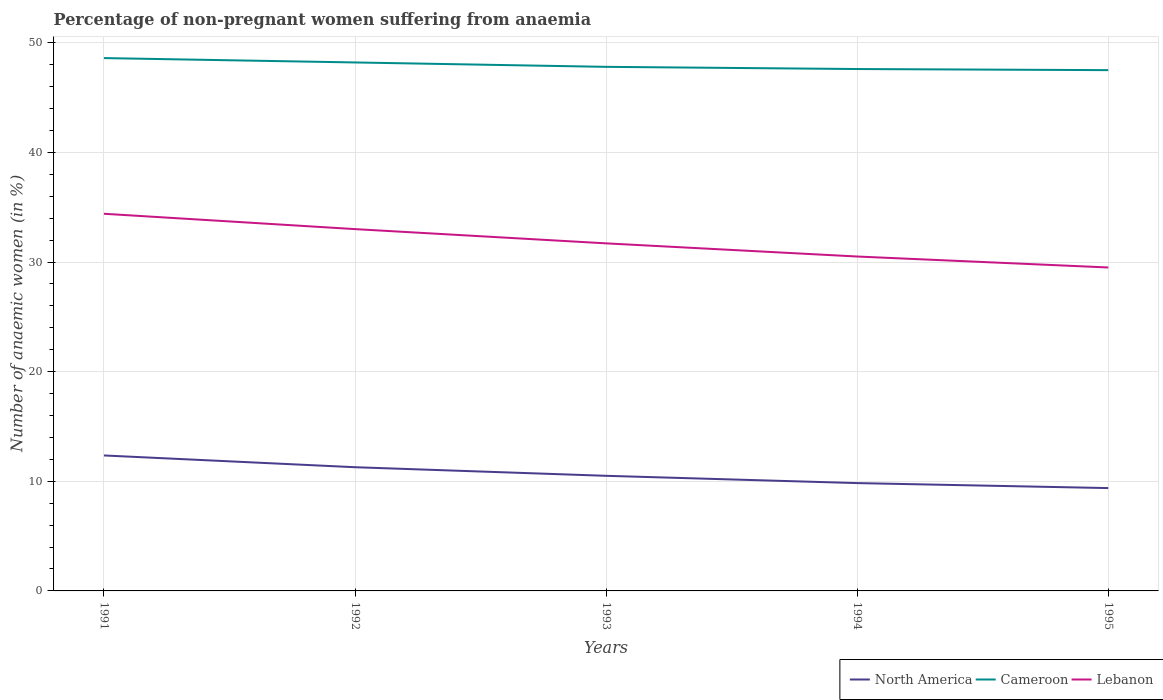How many different coloured lines are there?
Give a very brief answer. 3. Does the line corresponding to North America intersect with the line corresponding to Cameroon?
Your answer should be compact. No. Across all years, what is the maximum percentage of non-pregnant women suffering from anaemia in North America?
Offer a very short reply. 9.38. What is the total percentage of non-pregnant women suffering from anaemia in North America in the graph?
Keep it short and to the point. 1.45. What is the difference between the highest and the second highest percentage of non-pregnant women suffering from anaemia in Cameroon?
Your response must be concise. 1.1. What is the difference between the highest and the lowest percentage of non-pregnant women suffering from anaemia in Cameroon?
Keep it short and to the point. 2. Is the percentage of non-pregnant women suffering from anaemia in Cameroon strictly greater than the percentage of non-pregnant women suffering from anaemia in North America over the years?
Ensure brevity in your answer.  No. How many lines are there?
Offer a terse response. 3. How many years are there in the graph?
Provide a short and direct response. 5. Does the graph contain grids?
Keep it short and to the point. Yes. Where does the legend appear in the graph?
Give a very brief answer. Bottom right. How many legend labels are there?
Offer a very short reply. 3. How are the legend labels stacked?
Your response must be concise. Horizontal. What is the title of the graph?
Your response must be concise. Percentage of non-pregnant women suffering from anaemia. Does "Kiribati" appear as one of the legend labels in the graph?
Provide a succinct answer. No. What is the label or title of the Y-axis?
Your answer should be compact. Number of anaemic women (in %). What is the Number of anaemic women (in %) in North America in 1991?
Your answer should be very brief. 12.36. What is the Number of anaemic women (in %) in Cameroon in 1991?
Make the answer very short. 48.6. What is the Number of anaemic women (in %) of Lebanon in 1991?
Offer a very short reply. 34.4. What is the Number of anaemic women (in %) of North America in 1992?
Your answer should be compact. 11.28. What is the Number of anaemic women (in %) of Cameroon in 1992?
Your response must be concise. 48.2. What is the Number of anaemic women (in %) in Lebanon in 1992?
Ensure brevity in your answer.  33. What is the Number of anaemic women (in %) in North America in 1993?
Offer a very short reply. 10.5. What is the Number of anaemic women (in %) in Cameroon in 1993?
Offer a terse response. 47.8. What is the Number of anaemic women (in %) of Lebanon in 1993?
Your answer should be very brief. 31.7. What is the Number of anaemic women (in %) in North America in 1994?
Offer a very short reply. 9.83. What is the Number of anaemic women (in %) of Cameroon in 1994?
Keep it short and to the point. 47.6. What is the Number of anaemic women (in %) in Lebanon in 1994?
Ensure brevity in your answer.  30.5. What is the Number of anaemic women (in %) in North America in 1995?
Give a very brief answer. 9.38. What is the Number of anaemic women (in %) in Cameroon in 1995?
Your response must be concise. 47.5. What is the Number of anaemic women (in %) in Lebanon in 1995?
Make the answer very short. 29.5. Across all years, what is the maximum Number of anaemic women (in %) of North America?
Your response must be concise. 12.36. Across all years, what is the maximum Number of anaemic women (in %) of Cameroon?
Give a very brief answer. 48.6. Across all years, what is the maximum Number of anaemic women (in %) of Lebanon?
Your response must be concise. 34.4. Across all years, what is the minimum Number of anaemic women (in %) of North America?
Make the answer very short. 9.38. Across all years, what is the minimum Number of anaemic women (in %) of Cameroon?
Offer a terse response. 47.5. Across all years, what is the minimum Number of anaemic women (in %) in Lebanon?
Provide a succinct answer. 29.5. What is the total Number of anaemic women (in %) of North America in the graph?
Keep it short and to the point. 53.35. What is the total Number of anaemic women (in %) of Cameroon in the graph?
Your answer should be very brief. 239.7. What is the total Number of anaemic women (in %) of Lebanon in the graph?
Your answer should be very brief. 159.1. What is the difference between the Number of anaemic women (in %) in North America in 1991 and that in 1992?
Make the answer very short. 1.07. What is the difference between the Number of anaemic women (in %) of Cameroon in 1991 and that in 1992?
Give a very brief answer. 0.4. What is the difference between the Number of anaemic women (in %) of North America in 1991 and that in 1993?
Your response must be concise. 1.86. What is the difference between the Number of anaemic women (in %) of Lebanon in 1991 and that in 1993?
Offer a terse response. 2.7. What is the difference between the Number of anaemic women (in %) in North America in 1991 and that in 1994?
Your answer should be compact. 2.52. What is the difference between the Number of anaemic women (in %) in Lebanon in 1991 and that in 1994?
Offer a terse response. 3.9. What is the difference between the Number of anaemic women (in %) of North America in 1991 and that in 1995?
Give a very brief answer. 2.98. What is the difference between the Number of anaemic women (in %) in Cameroon in 1991 and that in 1995?
Ensure brevity in your answer.  1.1. What is the difference between the Number of anaemic women (in %) of North America in 1992 and that in 1993?
Provide a succinct answer. 0.78. What is the difference between the Number of anaemic women (in %) of Cameroon in 1992 and that in 1993?
Keep it short and to the point. 0.4. What is the difference between the Number of anaemic women (in %) of Lebanon in 1992 and that in 1993?
Keep it short and to the point. 1.3. What is the difference between the Number of anaemic women (in %) in North America in 1992 and that in 1994?
Provide a short and direct response. 1.45. What is the difference between the Number of anaemic women (in %) of North America in 1992 and that in 1995?
Provide a succinct answer. 1.9. What is the difference between the Number of anaemic women (in %) in Lebanon in 1992 and that in 1995?
Your answer should be very brief. 3.5. What is the difference between the Number of anaemic women (in %) in North America in 1993 and that in 1994?
Keep it short and to the point. 0.66. What is the difference between the Number of anaemic women (in %) of Lebanon in 1993 and that in 1994?
Your response must be concise. 1.2. What is the difference between the Number of anaemic women (in %) in North America in 1993 and that in 1995?
Provide a short and direct response. 1.12. What is the difference between the Number of anaemic women (in %) in Lebanon in 1993 and that in 1995?
Provide a succinct answer. 2.2. What is the difference between the Number of anaemic women (in %) in North America in 1994 and that in 1995?
Keep it short and to the point. 0.45. What is the difference between the Number of anaemic women (in %) in Cameroon in 1994 and that in 1995?
Give a very brief answer. 0.1. What is the difference between the Number of anaemic women (in %) of Lebanon in 1994 and that in 1995?
Offer a terse response. 1. What is the difference between the Number of anaemic women (in %) in North America in 1991 and the Number of anaemic women (in %) in Cameroon in 1992?
Keep it short and to the point. -35.84. What is the difference between the Number of anaemic women (in %) of North America in 1991 and the Number of anaemic women (in %) of Lebanon in 1992?
Offer a terse response. -20.64. What is the difference between the Number of anaemic women (in %) of Cameroon in 1991 and the Number of anaemic women (in %) of Lebanon in 1992?
Provide a succinct answer. 15.6. What is the difference between the Number of anaemic women (in %) in North America in 1991 and the Number of anaemic women (in %) in Cameroon in 1993?
Keep it short and to the point. -35.44. What is the difference between the Number of anaemic women (in %) of North America in 1991 and the Number of anaemic women (in %) of Lebanon in 1993?
Your answer should be very brief. -19.34. What is the difference between the Number of anaemic women (in %) in Cameroon in 1991 and the Number of anaemic women (in %) in Lebanon in 1993?
Your answer should be compact. 16.9. What is the difference between the Number of anaemic women (in %) of North America in 1991 and the Number of anaemic women (in %) of Cameroon in 1994?
Your response must be concise. -35.24. What is the difference between the Number of anaemic women (in %) of North America in 1991 and the Number of anaemic women (in %) of Lebanon in 1994?
Offer a very short reply. -18.14. What is the difference between the Number of anaemic women (in %) of Cameroon in 1991 and the Number of anaemic women (in %) of Lebanon in 1994?
Provide a succinct answer. 18.1. What is the difference between the Number of anaemic women (in %) in North America in 1991 and the Number of anaemic women (in %) in Cameroon in 1995?
Your answer should be very brief. -35.14. What is the difference between the Number of anaemic women (in %) in North America in 1991 and the Number of anaemic women (in %) in Lebanon in 1995?
Your answer should be compact. -17.14. What is the difference between the Number of anaemic women (in %) in Cameroon in 1991 and the Number of anaemic women (in %) in Lebanon in 1995?
Provide a succinct answer. 19.1. What is the difference between the Number of anaemic women (in %) in North America in 1992 and the Number of anaemic women (in %) in Cameroon in 1993?
Provide a short and direct response. -36.52. What is the difference between the Number of anaemic women (in %) of North America in 1992 and the Number of anaemic women (in %) of Lebanon in 1993?
Provide a short and direct response. -20.42. What is the difference between the Number of anaemic women (in %) in Cameroon in 1992 and the Number of anaemic women (in %) in Lebanon in 1993?
Offer a very short reply. 16.5. What is the difference between the Number of anaemic women (in %) of North America in 1992 and the Number of anaemic women (in %) of Cameroon in 1994?
Make the answer very short. -36.32. What is the difference between the Number of anaemic women (in %) in North America in 1992 and the Number of anaemic women (in %) in Lebanon in 1994?
Ensure brevity in your answer.  -19.22. What is the difference between the Number of anaemic women (in %) of Cameroon in 1992 and the Number of anaemic women (in %) of Lebanon in 1994?
Keep it short and to the point. 17.7. What is the difference between the Number of anaemic women (in %) in North America in 1992 and the Number of anaemic women (in %) in Cameroon in 1995?
Your response must be concise. -36.22. What is the difference between the Number of anaemic women (in %) in North America in 1992 and the Number of anaemic women (in %) in Lebanon in 1995?
Provide a succinct answer. -18.22. What is the difference between the Number of anaemic women (in %) of North America in 1993 and the Number of anaemic women (in %) of Cameroon in 1994?
Give a very brief answer. -37.1. What is the difference between the Number of anaemic women (in %) in North America in 1993 and the Number of anaemic women (in %) in Lebanon in 1994?
Your answer should be very brief. -20. What is the difference between the Number of anaemic women (in %) of Cameroon in 1993 and the Number of anaemic women (in %) of Lebanon in 1994?
Provide a short and direct response. 17.3. What is the difference between the Number of anaemic women (in %) of North America in 1993 and the Number of anaemic women (in %) of Cameroon in 1995?
Give a very brief answer. -37. What is the difference between the Number of anaemic women (in %) in North America in 1993 and the Number of anaemic women (in %) in Lebanon in 1995?
Your answer should be compact. -19. What is the difference between the Number of anaemic women (in %) of Cameroon in 1993 and the Number of anaemic women (in %) of Lebanon in 1995?
Your response must be concise. 18.3. What is the difference between the Number of anaemic women (in %) in North America in 1994 and the Number of anaemic women (in %) in Cameroon in 1995?
Your answer should be compact. -37.67. What is the difference between the Number of anaemic women (in %) of North America in 1994 and the Number of anaemic women (in %) of Lebanon in 1995?
Your answer should be compact. -19.67. What is the difference between the Number of anaemic women (in %) in Cameroon in 1994 and the Number of anaemic women (in %) in Lebanon in 1995?
Provide a short and direct response. 18.1. What is the average Number of anaemic women (in %) of North America per year?
Your answer should be very brief. 10.67. What is the average Number of anaemic women (in %) in Cameroon per year?
Your answer should be very brief. 47.94. What is the average Number of anaemic women (in %) in Lebanon per year?
Offer a terse response. 31.82. In the year 1991, what is the difference between the Number of anaemic women (in %) of North America and Number of anaemic women (in %) of Cameroon?
Provide a short and direct response. -36.24. In the year 1991, what is the difference between the Number of anaemic women (in %) in North America and Number of anaemic women (in %) in Lebanon?
Ensure brevity in your answer.  -22.04. In the year 1992, what is the difference between the Number of anaemic women (in %) in North America and Number of anaemic women (in %) in Cameroon?
Provide a succinct answer. -36.92. In the year 1992, what is the difference between the Number of anaemic women (in %) in North America and Number of anaemic women (in %) in Lebanon?
Your answer should be very brief. -21.72. In the year 1993, what is the difference between the Number of anaemic women (in %) in North America and Number of anaemic women (in %) in Cameroon?
Offer a terse response. -37.3. In the year 1993, what is the difference between the Number of anaemic women (in %) in North America and Number of anaemic women (in %) in Lebanon?
Make the answer very short. -21.2. In the year 1993, what is the difference between the Number of anaemic women (in %) in Cameroon and Number of anaemic women (in %) in Lebanon?
Offer a terse response. 16.1. In the year 1994, what is the difference between the Number of anaemic women (in %) of North America and Number of anaemic women (in %) of Cameroon?
Make the answer very short. -37.77. In the year 1994, what is the difference between the Number of anaemic women (in %) in North America and Number of anaemic women (in %) in Lebanon?
Offer a very short reply. -20.67. In the year 1995, what is the difference between the Number of anaemic women (in %) in North America and Number of anaemic women (in %) in Cameroon?
Offer a very short reply. -38.12. In the year 1995, what is the difference between the Number of anaemic women (in %) in North America and Number of anaemic women (in %) in Lebanon?
Keep it short and to the point. -20.12. What is the ratio of the Number of anaemic women (in %) of North America in 1991 to that in 1992?
Offer a terse response. 1.1. What is the ratio of the Number of anaemic women (in %) of Cameroon in 1991 to that in 1992?
Your response must be concise. 1.01. What is the ratio of the Number of anaemic women (in %) of Lebanon in 1991 to that in 1992?
Your answer should be very brief. 1.04. What is the ratio of the Number of anaemic women (in %) in North America in 1991 to that in 1993?
Offer a terse response. 1.18. What is the ratio of the Number of anaemic women (in %) in Cameroon in 1991 to that in 1993?
Offer a terse response. 1.02. What is the ratio of the Number of anaemic women (in %) in Lebanon in 1991 to that in 1993?
Your response must be concise. 1.09. What is the ratio of the Number of anaemic women (in %) of North America in 1991 to that in 1994?
Make the answer very short. 1.26. What is the ratio of the Number of anaemic women (in %) in Cameroon in 1991 to that in 1994?
Your answer should be compact. 1.02. What is the ratio of the Number of anaemic women (in %) in Lebanon in 1991 to that in 1994?
Give a very brief answer. 1.13. What is the ratio of the Number of anaemic women (in %) in North America in 1991 to that in 1995?
Provide a short and direct response. 1.32. What is the ratio of the Number of anaemic women (in %) in Cameroon in 1991 to that in 1995?
Your answer should be very brief. 1.02. What is the ratio of the Number of anaemic women (in %) in Lebanon in 1991 to that in 1995?
Your answer should be very brief. 1.17. What is the ratio of the Number of anaemic women (in %) of North America in 1992 to that in 1993?
Offer a very short reply. 1.07. What is the ratio of the Number of anaemic women (in %) in Cameroon in 1992 to that in 1993?
Provide a succinct answer. 1.01. What is the ratio of the Number of anaemic women (in %) in Lebanon in 1992 to that in 1993?
Your answer should be compact. 1.04. What is the ratio of the Number of anaemic women (in %) in North America in 1992 to that in 1994?
Your answer should be very brief. 1.15. What is the ratio of the Number of anaemic women (in %) of Cameroon in 1992 to that in 1994?
Give a very brief answer. 1.01. What is the ratio of the Number of anaemic women (in %) of Lebanon in 1992 to that in 1994?
Offer a very short reply. 1.08. What is the ratio of the Number of anaemic women (in %) in North America in 1992 to that in 1995?
Ensure brevity in your answer.  1.2. What is the ratio of the Number of anaemic women (in %) of Cameroon in 1992 to that in 1995?
Make the answer very short. 1.01. What is the ratio of the Number of anaemic women (in %) of Lebanon in 1992 to that in 1995?
Offer a terse response. 1.12. What is the ratio of the Number of anaemic women (in %) in North America in 1993 to that in 1994?
Keep it short and to the point. 1.07. What is the ratio of the Number of anaemic women (in %) of Lebanon in 1993 to that in 1994?
Your answer should be very brief. 1.04. What is the ratio of the Number of anaemic women (in %) in North America in 1993 to that in 1995?
Keep it short and to the point. 1.12. What is the ratio of the Number of anaemic women (in %) in Lebanon in 1993 to that in 1995?
Your answer should be compact. 1.07. What is the ratio of the Number of anaemic women (in %) of North America in 1994 to that in 1995?
Your answer should be compact. 1.05. What is the ratio of the Number of anaemic women (in %) of Cameroon in 1994 to that in 1995?
Provide a short and direct response. 1. What is the ratio of the Number of anaemic women (in %) in Lebanon in 1994 to that in 1995?
Provide a succinct answer. 1.03. What is the difference between the highest and the second highest Number of anaemic women (in %) in North America?
Keep it short and to the point. 1.07. What is the difference between the highest and the second highest Number of anaemic women (in %) of Cameroon?
Make the answer very short. 0.4. What is the difference between the highest and the second highest Number of anaemic women (in %) in Lebanon?
Your answer should be very brief. 1.4. What is the difference between the highest and the lowest Number of anaemic women (in %) of North America?
Offer a terse response. 2.98. What is the difference between the highest and the lowest Number of anaemic women (in %) in Cameroon?
Offer a very short reply. 1.1. 